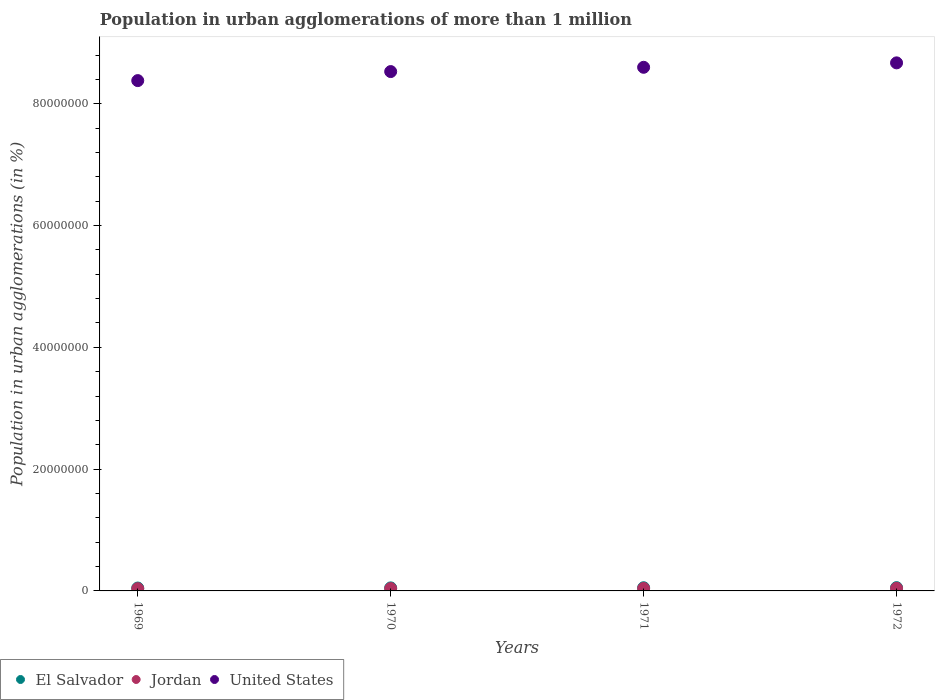What is the population in urban agglomerations in Jordan in 1972?
Make the answer very short. 4.29e+05. Across all years, what is the maximum population in urban agglomerations in Jordan?
Your response must be concise. 4.29e+05. Across all years, what is the minimum population in urban agglomerations in El Salvador?
Your response must be concise. 4.76e+05. In which year was the population in urban agglomerations in El Salvador maximum?
Your answer should be compact. 1972. In which year was the population in urban agglomerations in Jordan minimum?
Keep it short and to the point. 1969. What is the total population in urban agglomerations in Jordan in the graph?
Offer a terse response. 1.59e+06. What is the difference between the population in urban agglomerations in El Salvador in 1969 and that in 1971?
Provide a short and direct response. -4.72e+04. What is the difference between the population in urban agglomerations in El Salvador in 1971 and the population in urban agglomerations in Jordan in 1972?
Give a very brief answer. 9.43e+04. What is the average population in urban agglomerations in United States per year?
Give a very brief answer. 8.55e+07. In the year 1970, what is the difference between the population in urban agglomerations in Jordan and population in urban agglomerations in United States?
Offer a very short reply. -8.49e+07. In how many years, is the population in urban agglomerations in Jordan greater than 4000000 %?
Give a very brief answer. 0. What is the ratio of the population in urban agglomerations in Jordan in 1970 to that in 1972?
Provide a succinct answer. 0.9. Is the population in urban agglomerations in United States in 1970 less than that in 1972?
Ensure brevity in your answer.  Yes. What is the difference between the highest and the second highest population in urban agglomerations in Jordan?
Give a very brief answer. 2.13e+04. What is the difference between the highest and the lowest population in urban agglomerations in United States?
Offer a very short reply. 2.91e+06. Is it the case that in every year, the sum of the population in urban agglomerations in Jordan and population in urban agglomerations in El Salvador  is greater than the population in urban agglomerations in United States?
Give a very brief answer. No. Is the population in urban agglomerations in Jordan strictly less than the population in urban agglomerations in El Salvador over the years?
Make the answer very short. Yes. How many dotlines are there?
Your response must be concise. 3. How many years are there in the graph?
Make the answer very short. 4. What is the difference between two consecutive major ticks on the Y-axis?
Offer a terse response. 2.00e+07. Does the graph contain grids?
Keep it short and to the point. No. What is the title of the graph?
Offer a terse response. Population in urban agglomerations of more than 1 million. What is the label or title of the X-axis?
Offer a very short reply. Years. What is the label or title of the Y-axis?
Give a very brief answer. Population in urban agglomerations (in %). What is the Population in urban agglomerations (in %) in El Salvador in 1969?
Your answer should be very brief. 4.76e+05. What is the Population in urban agglomerations (in %) of Jordan in 1969?
Offer a terse response. 3.69e+05. What is the Population in urban agglomerations (in %) of United States in 1969?
Offer a terse response. 8.38e+07. What is the Population in urban agglomerations (in %) of El Salvador in 1970?
Your response must be concise. 5.00e+05. What is the Population in urban agglomerations (in %) of Jordan in 1970?
Offer a terse response. 3.88e+05. What is the Population in urban agglomerations (in %) in United States in 1970?
Make the answer very short. 8.53e+07. What is the Population in urban agglomerations (in %) of El Salvador in 1971?
Give a very brief answer. 5.24e+05. What is the Population in urban agglomerations (in %) in Jordan in 1971?
Offer a terse response. 4.08e+05. What is the Population in urban agglomerations (in %) in United States in 1971?
Your response must be concise. 8.60e+07. What is the Population in urban agglomerations (in %) of El Salvador in 1972?
Your response must be concise. 5.41e+05. What is the Population in urban agglomerations (in %) in Jordan in 1972?
Provide a succinct answer. 4.29e+05. What is the Population in urban agglomerations (in %) of United States in 1972?
Ensure brevity in your answer.  8.67e+07. Across all years, what is the maximum Population in urban agglomerations (in %) of El Salvador?
Your answer should be very brief. 5.41e+05. Across all years, what is the maximum Population in urban agglomerations (in %) of Jordan?
Make the answer very short. 4.29e+05. Across all years, what is the maximum Population in urban agglomerations (in %) in United States?
Your response must be concise. 8.67e+07. Across all years, what is the minimum Population in urban agglomerations (in %) in El Salvador?
Your answer should be very brief. 4.76e+05. Across all years, what is the minimum Population in urban agglomerations (in %) of Jordan?
Provide a short and direct response. 3.69e+05. Across all years, what is the minimum Population in urban agglomerations (in %) of United States?
Ensure brevity in your answer.  8.38e+07. What is the total Population in urban agglomerations (in %) of El Salvador in the graph?
Ensure brevity in your answer.  2.04e+06. What is the total Population in urban agglomerations (in %) in Jordan in the graph?
Your answer should be compact. 1.59e+06. What is the total Population in urban agglomerations (in %) of United States in the graph?
Your answer should be compact. 3.42e+08. What is the difference between the Population in urban agglomerations (in %) in El Salvador in 1969 and that in 1970?
Your response must be concise. -2.31e+04. What is the difference between the Population in urban agglomerations (in %) in Jordan in 1969 and that in 1970?
Ensure brevity in your answer.  -1.92e+04. What is the difference between the Population in urban agglomerations (in %) of United States in 1969 and that in 1970?
Give a very brief answer. -1.48e+06. What is the difference between the Population in urban agglomerations (in %) of El Salvador in 1969 and that in 1971?
Provide a succinct answer. -4.72e+04. What is the difference between the Population in urban agglomerations (in %) of Jordan in 1969 and that in 1971?
Provide a short and direct response. -3.94e+04. What is the difference between the Population in urban agglomerations (in %) of United States in 1969 and that in 1971?
Offer a terse response. -2.19e+06. What is the difference between the Population in urban agglomerations (in %) in El Salvador in 1969 and that in 1972?
Offer a very short reply. -6.45e+04. What is the difference between the Population in urban agglomerations (in %) of Jordan in 1969 and that in 1972?
Provide a succinct answer. -6.07e+04. What is the difference between the Population in urban agglomerations (in %) of United States in 1969 and that in 1972?
Offer a terse response. -2.91e+06. What is the difference between the Population in urban agglomerations (in %) in El Salvador in 1970 and that in 1971?
Keep it short and to the point. -2.42e+04. What is the difference between the Population in urban agglomerations (in %) of Jordan in 1970 and that in 1971?
Provide a succinct answer. -2.02e+04. What is the difference between the Population in urban agglomerations (in %) of United States in 1970 and that in 1971?
Make the answer very short. -7.03e+05. What is the difference between the Population in urban agglomerations (in %) in El Salvador in 1970 and that in 1972?
Your answer should be compact. -4.14e+04. What is the difference between the Population in urban agglomerations (in %) in Jordan in 1970 and that in 1972?
Keep it short and to the point. -4.15e+04. What is the difference between the Population in urban agglomerations (in %) in United States in 1970 and that in 1972?
Keep it short and to the point. -1.43e+06. What is the difference between the Population in urban agglomerations (in %) of El Salvador in 1971 and that in 1972?
Your answer should be very brief. -1.73e+04. What is the difference between the Population in urban agglomerations (in %) of Jordan in 1971 and that in 1972?
Provide a short and direct response. -2.13e+04. What is the difference between the Population in urban agglomerations (in %) of United States in 1971 and that in 1972?
Your response must be concise. -7.27e+05. What is the difference between the Population in urban agglomerations (in %) of El Salvador in 1969 and the Population in urban agglomerations (in %) of Jordan in 1970?
Give a very brief answer. 8.86e+04. What is the difference between the Population in urban agglomerations (in %) in El Salvador in 1969 and the Population in urban agglomerations (in %) in United States in 1970?
Offer a very short reply. -8.48e+07. What is the difference between the Population in urban agglomerations (in %) of Jordan in 1969 and the Population in urban agglomerations (in %) of United States in 1970?
Keep it short and to the point. -8.49e+07. What is the difference between the Population in urban agglomerations (in %) in El Salvador in 1969 and the Population in urban agglomerations (in %) in Jordan in 1971?
Your response must be concise. 6.84e+04. What is the difference between the Population in urban agglomerations (in %) of El Salvador in 1969 and the Population in urban agglomerations (in %) of United States in 1971?
Keep it short and to the point. -8.55e+07. What is the difference between the Population in urban agglomerations (in %) of Jordan in 1969 and the Population in urban agglomerations (in %) of United States in 1971?
Keep it short and to the point. -8.56e+07. What is the difference between the Population in urban agglomerations (in %) of El Salvador in 1969 and the Population in urban agglomerations (in %) of Jordan in 1972?
Keep it short and to the point. 4.71e+04. What is the difference between the Population in urban agglomerations (in %) of El Salvador in 1969 and the Population in urban agglomerations (in %) of United States in 1972?
Provide a short and direct response. -8.62e+07. What is the difference between the Population in urban agglomerations (in %) of Jordan in 1969 and the Population in urban agglomerations (in %) of United States in 1972?
Ensure brevity in your answer.  -8.64e+07. What is the difference between the Population in urban agglomerations (in %) of El Salvador in 1970 and the Population in urban agglomerations (in %) of Jordan in 1971?
Keep it short and to the point. 9.15e+04. What is the difference between the Population in urban agglomerations (in %) of El Salvador in 1970 and the Population in urban agglomerations (in %) of United States in 1971?
Offer a terse response. -8.55e+07. What is the difference between the Population in urban agglomerations (in %) in Jordan in 1970 and the Population in urban agglomerations (in %) in United States in 1971?
Keep it short and to the point. -8.56e+07. What is the difference between the Population in urban agglomerations (in %) in El Salvador in 1970 and the Population in urban agglomerations (in %) in Jordan in 1972?
Your answer should be compact. 7.02e+04. What is the difference between the Population in urban agglomerations (in %) of El Salvador in 1970 and the Population in urban agglomerations (in %) of United States in 1972?
Provide a short and direct response. -8.62e+07. What is the difference between the Population in urban agglomerations (in %) of Jordan in 1970 and the Population in urban agglomerations (in %) of United States in 1972?
Your response must be concise. -8.63e+07. What is the difference between the Population in urban agglomerations (in %) of El Salvador in 1971 and the Population in urban agglomerations (in %) of Jordan in 1972?
Offer a very short reply. 9.43e+04. What is the difference between the Population in urban agglomerations (in %) of El Salvador in 1971 and the Population in urban agglomerations (in %) of United States in 1972?
Keep it short and to the point. -8.62e+07. What is the difference between the Population in urban agglomerations (in %) of Jordan in 1971 and the Population in urban agglomerations (in %) of United States in 1972?
Your answer should be compact. -8.63e+07. What is the average Population in urban agglomerations (in %) in El Salvador per year?
Your answer should be very brief. 5.10e+05. What is the average Population in urban agglomerations (in %) of Jordan per year?
Give a very brief answer. 3.98e+05. What is the average Population in urban agglomerations (in %) of United States per year?
Ensure brevity in your answer.  8.55e+07. In the year 1969, what is the difference between the Population in urban agglomerations (in %) in El Salvador and Population in urban agglomerations (in %) in Jordan?
Ensure brevity in your answer.  1.08e+05. In the year 1969, what is the difference between the Population in urban agglomerations (in %) in El Salvador and Population in urban agglomerations (in %) in United States?
Keep it short and to the point. -8.33e+07. In the year 1969, what is the difference between the Population in urban agglomerations (in %) in Jordan and Population in urban agglomerations (in %) in United States?
Provide a succinct answer. -8.34e+07. In the year 1970, what is the difference between the Population in urban agglomerations (in %) in El Salvador and Population in urban agglomerations (in %) in Jordan?
Give a very brief answer. 1.12e+05. In the year 1970, what is the difference between the Population in urban agglomerations (in %) of El Salvador and Population in urban agglomerations (in %) of United States?
Provide a short and direct response. -8.48e+07. In the year 1970, what is the difference between the Population in urban agglomerations (in %) in Jordan and Population in urban agglomerations (in %) in United States?
Offer a terse response. -8.49e+07. In the year 1971, what is the difference between the Population in urban agglomerations (in %) of El Salvador and Population in urban agglomerations (in %) of Jordan?
Ensure brevity in your answer.  1.16e+05. In the year 1971, what is the difference between the Population in urban agglomerations (in %) in El Salvador and Population in urban agglomerations (in %) in United States?
Offer a terse response. -8.55e+07. In the year 1971, what is the difference between the Population in urban agglomerations (in %) of Jordan and Population in urban agglomerations (in %) of United States?
Make the answer very short. -8.56e+07. In the year 1972, what is the difference between the Population in urban agglomerations (in %) of El Salvador and Population in urban agglomerations (in %) of Jordan?
Offer a very short reply. 1.12e+05. In the year 1972, what is the difference between the Population in urban agglomerations (in %) of El Salvador and Population in urban agglomerations (in %) of United States?
Provide a succinct answer. -8.62e+07. In the year 1972, what is the difference between the Population in urban agglomerations (in %) of Jordan and Population in urban agglomerations (in %) of United States?
Make the answer very short. -8.63e+07. What is the ratio of the Population in urban agglomerations (in %) of El Salvador in 1969 to that in 1970?
Provide a succinct answer. 0.95. What is the ratio of the Population in urban agglomerations (in %) of Jordan in 1969 to that in 1970?
Offer a terse response. 0.95. What is the ratio of the Population in urban agglomerations (in %) in United States in 1969 to that in 1970?
Offer a terse response. 0.98. What is the ratio of the Population in urban agglomerations (in %) in El Salvador in 1969 to that in 1971?
Your answer should be compact. 0.91. What is the ratio of the Population in urban agglomerations (in %) of Jordan in 1969 to that in 1971?
Provide a short and direct response. 0.9. What is the ratio of the Population in urban agglomerations (in %) in United States in 1969 to that in 1971?
Provide a succinct answer. 0.97. What is the ratio of the Population in urban agglomerations (in %) in El Salvador in 1969 to that in 1972?
Offer a very short reply. 0.88. What is the ratio of the Population in urban agglomerations (in %) in Jordan in 1969 to that in 1972?
Offer a terse response. 0.86. What is the ratio of the Population in urban agglomerations (in %) in United States in 1969 to that in 1972?
Offer a terse response. 0.97. What is the ratio of the Population in urban agglomerations (in %) of El Salvador in 1970 to that in 1971?
Provide a succinct answer. 0.95. What is the ratio of the Population in urban agglomerations (in %) in Jordan in 1970 to that in 1971?
Your response must be concise. 0.95. What is the ratio of the Population in urban agglomerations (in %) in United States in 1970 to that in 1971?
Keep it short and to the point. 0.99. What is the ratio of the Population in urban agglomerations (in %) of El Salvador in 1970 to that in 1972?
Keep it short and to the point. 0.92. What is the ratio of the Population in urban agglomerations (in %) of Jordan in 1970 to that in 1972?
Ensure brevity in your answer.  0.9. What is the ratio of the Population in urban agglomerations (in %) of United States in 1970 to that in 1972?
Keep it short and to the point. 0.98. What is the ratio of the Population in urban agglomerations (in %) in El Salvador in 1971 to that in 1972?
Give a very brief answer. 0.97. What is the ratio of the Population in urban agglomerations (in %) of Jordan in 1971 to that in 1972?
Your answer should be compact. 0.95. What is the difference between the highest and the second highest Population in urban agglomerations (in %) of El Salvador?
Your answer should be compact. 1.73e+04. What is the difference between the highest and the second highest Population in urban agglomerations (in %) of Jordan?
Your answer should be very brief. 2.13e+04. What is the difference between the highest and the second highest Population in urban agglomerations (in %) of United States?
Offer a terse response. 7.27e+05. What is the difference between the highest and the lowest Population in urban agglomerations (in %) in El Salvador?
Your answer should be very brief. 6.45e+04. What is the difference between the highest and the lowest Population in urban agglomerations (in %) in Jordan?
Your answer should be compact. 6.07e+04. What is the difference between the highest and the lowest Population in urban agglomerations (in %) of United States?
Provide a succinct answer. 2.91e+06. 